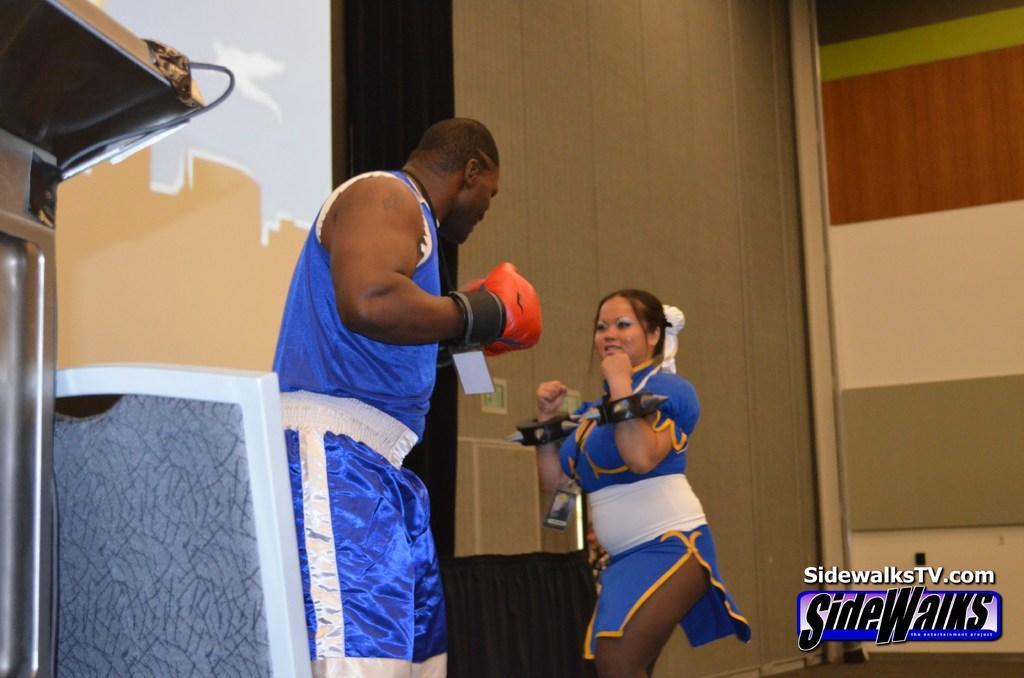In one or two sentences, can you explain what this image depicts? In this picture, we can see a few people, and we can see the wall and some objects on the left side of the picture, we can see some text and logo on the bottom right side of the picture. 